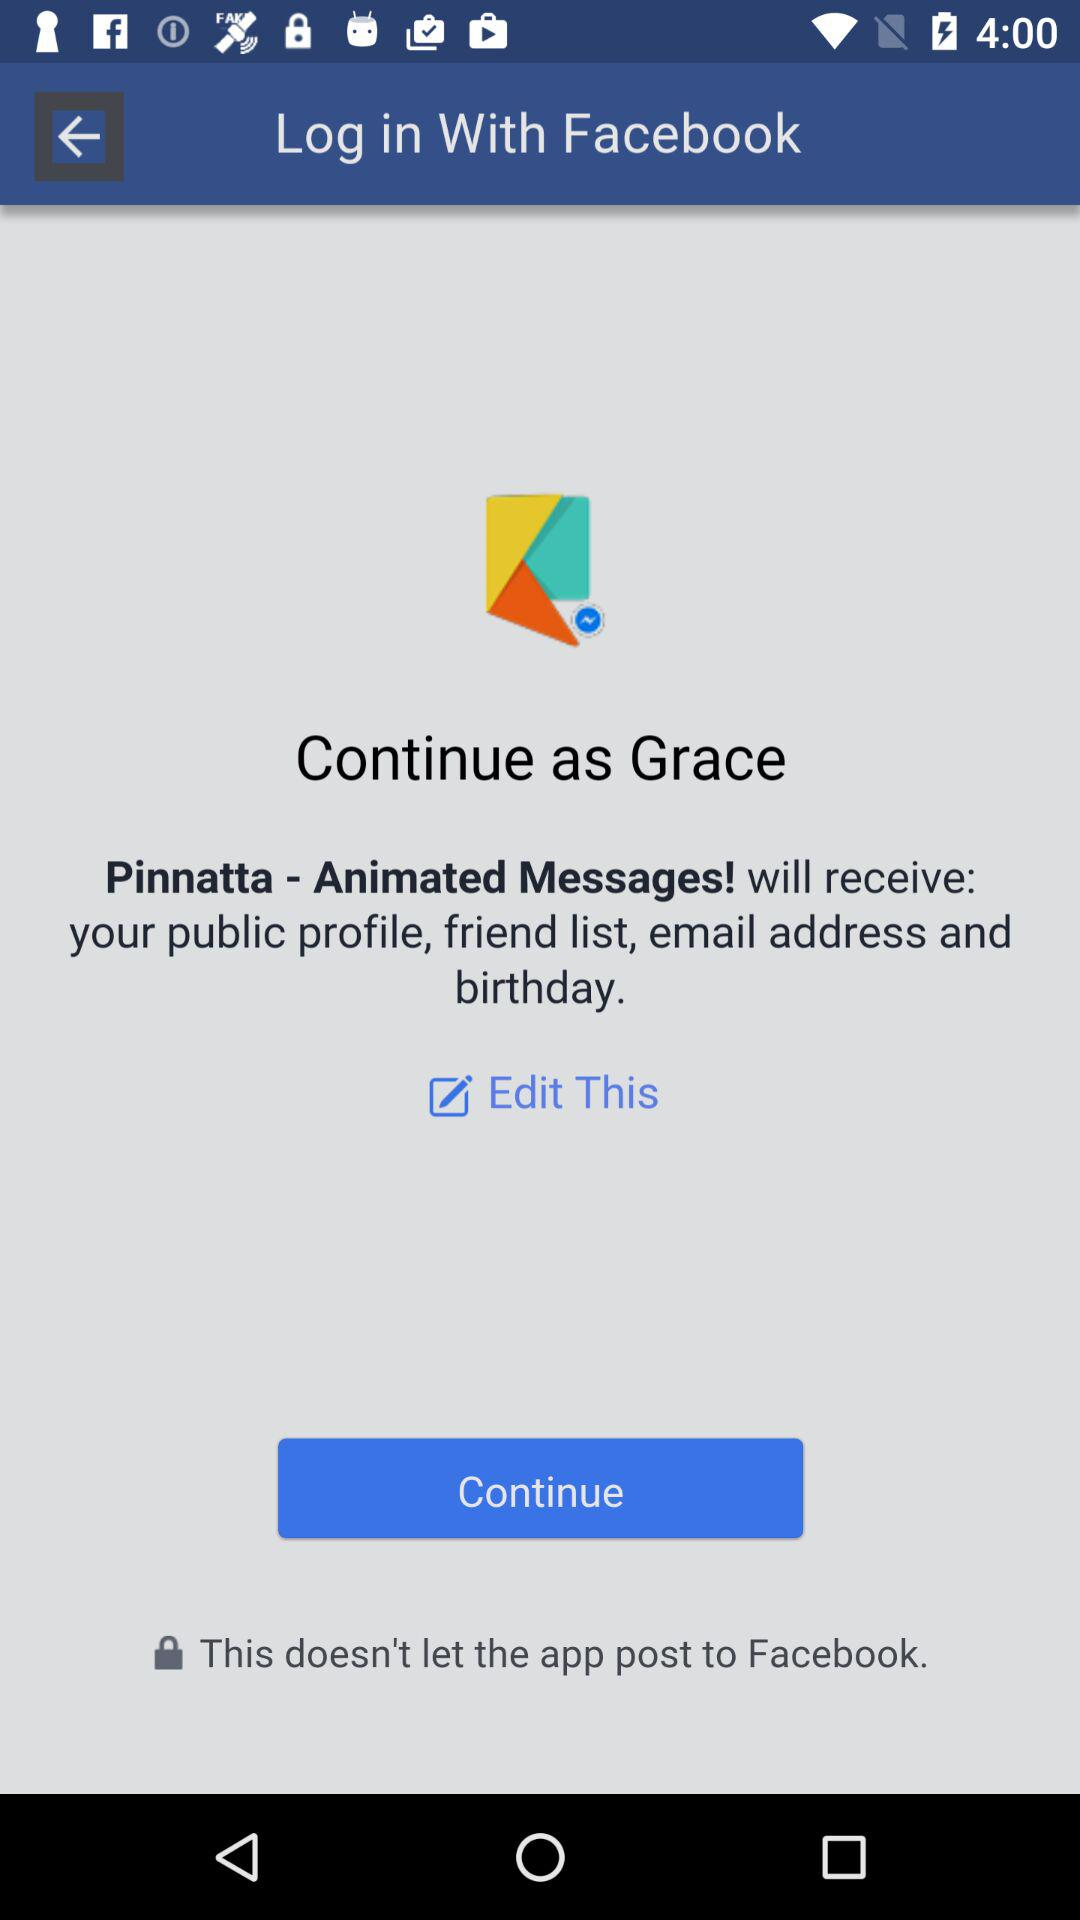By what user name can the application be continued? You can continue with Grace. 